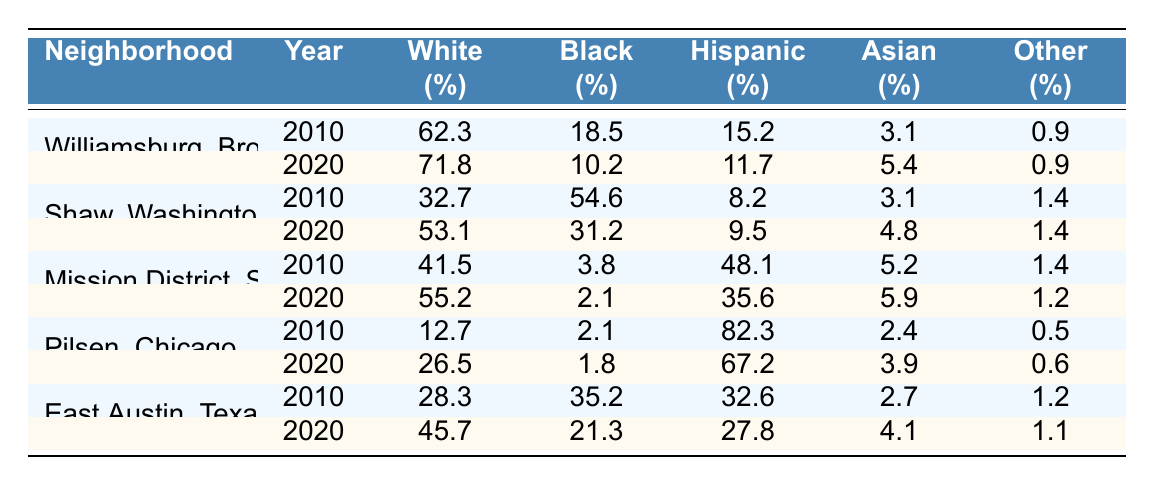What was the percentage of Black residents in Williamsburg, Brooklyn in 2010? The table shows that in 2010, the percentage of Black residents in Williamsburg, Brooklyn was 18.5%.
Answer: 18.5% What is the percentage increase of White residents in Shaw, Washington D.C. from 2010 to 2020? The percentage of White residents in 2010 was 32.7%, and in 2020 it was 53.1%. The increase is calculated as 53.1% - 32.7% = 20.4%.
Answer: 20.4% In which neighborhood did Hispanic residents make up the majority in 2010? According to the table, Pilsen, Chicago had the highest percentage of Hispanic residents in 2010 at 82.3%.
Answer: Pilsen, Chicago What is the total percentage of Asian residents in the Mission District, San Francisco for the years 2010 and 2020 combined? The percentage of Asian residents in the Mission District was 5.2% in 2010 and 5.9% in 2020. To find the total percentage, add them: 5.2% + 5.9% = 11.1%.
Answer: 11.1% Did the percentage of Black residents in East Austin, Texas increase or decrease from 2010 to 2020? In 2010, the percentage of Black residents was 35.2%, and in 2020 it decreased to 21.3%. This indicates a decrease in the percentage of Black residents.
Answer: Decrease What was the difference in the percentage of Hispanic residents between Williamsburg, Brooklyn, and Pilsen, Chicago in 2020? In 2020, Williamsburg, Brooklyn had 11.7% Hispanic residents and Pilsen, Chicago had 67.2%. The difference is 67.2% - 11.7% = 55.5%.
Answer: 55.5% Which neighborhood had the highest percentage of Other race residents in 2020? In 2020, all neighborhoods had 0.9% or lower for Other race residents. Williamsburg and Shaw, Washington D.C., both had 0.9% and 1.4% respectively. However, Shaw had a higher percentage among those.
Answer: Shaw, Washington D.C What was the average percentage of White residents across all neighborhoods in 2020? In 2020 the percentages of White residents in the neighborhoods were 71.8%, 53.1%, 55.2%, 26.5%, and 45.7%. The sum is 71.8 + 53.1 + 55.2 + 26.5 + 45.7 = 252.3%. Dividing by 5 neighborhoods gives an average of 252.3 / 5 = 50.46%.
Answer: 50.46% What was the change in the percentage of Hispanic residents in the Mission District, San Francisco from 2010 to 2020? In 2010, the percentage of Hispanic residents was 48.1%, and in 2020 it dropped to 35.6%. The change is 48.1% - 35.6% = 12.5%.
Answer: 12.5% reduction 